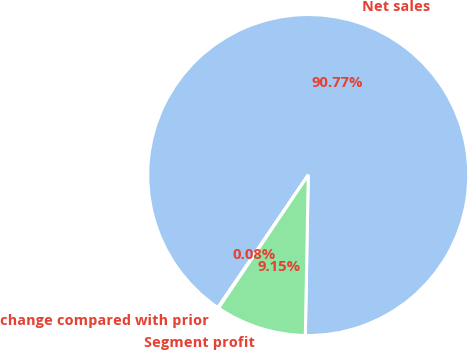<chart> <loc_0><loc_0><loc_500><loc_500><pie_chart><fcel>Net sales<fcel>change compared with prior<fcel>Segment profit<nl><fcel>90.76%<fcel>0.08%<fcel>9.15%<nl></chart> 